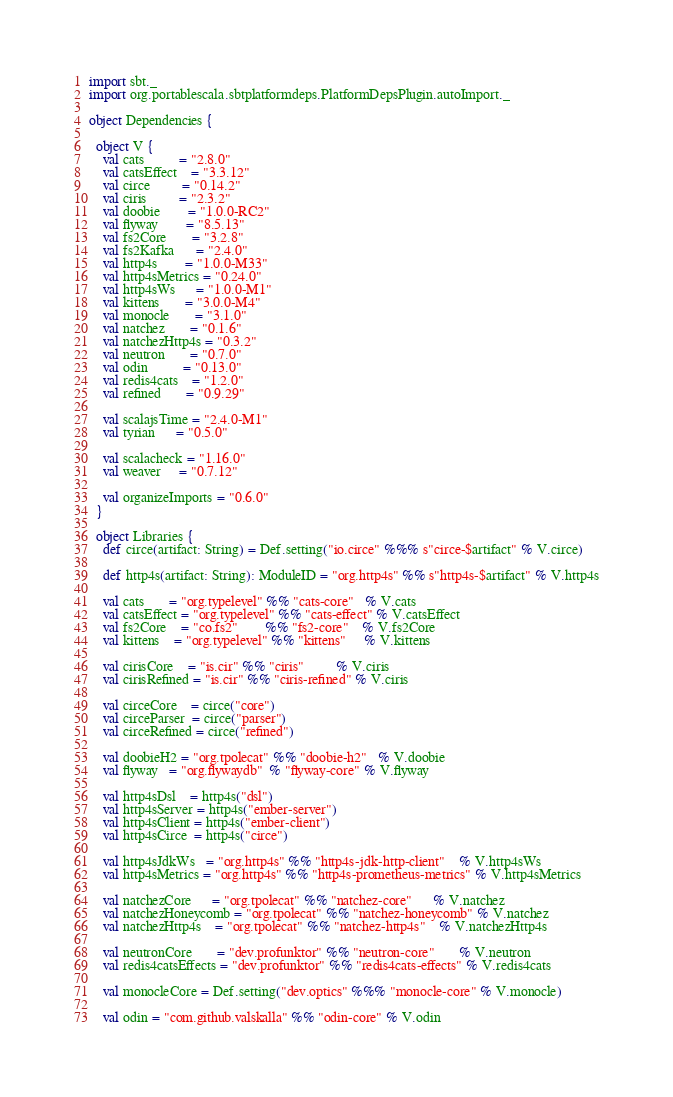<code> <loc_0><loc_0><loc_500><loc_500><_Scala_>import sbt._
import org.portablescala.sbtplatformdeps.PlatformDepsPlugin.autoImport._

object Dependencies {

  object V {
    val cats          = "2.8.0"
    val catsEffect    = "3.3.12"
    val circe         = "0.14.2"
    val ciris         = "2.3.2"
    val doobie        = "1.0.0-RC2"
    val flyway        = "8.5.13"
    val fs2Core       = "3.2.8"
    val fs2Kafka      = "2.4.0"
    val http4s        = "1.0.0-M33"
    val http4sMetrics = "0.24.0"
    val http4sWs      = "1.0.0-M1"
    val kittens       = "3.0.0-M4"
    val monocle       = "3.1.0"
    val natchez       = "0.1.6"
    val natchezHttp4s = "0.3.2"
    val neutron       = "0.7.0"
    val odin          = "0.13.0"
    val redis4cats    = "1.2.0"
    val refined       = "0.9.29"

    val scalajsTime = "2.4.0-M1"
    val tyrian      = "0.5.0"

    val scalacheck = "1.16.0"
    val weaver     = "0.7.12"

    val organizeImports = "0.6.0"
  }

  object Libraries {
    def circe(artifact: String) = Def.setting("io.circe" %%% s"circe-$artifact" % V.circe)

    def http4s(artifact: String): ModuleID = "org.http4s" %% s"http4s-$artifact" % V.http4s

    val cats       = "org.typelevel" %% "cats-core"   % V.cats
    val catsEffect = "org.typelevel" %% "cats-effect" % V.catsEffect
    val fs2Core    = "co.fs2"        %% "fs2-core"    % V.fs2Core
    val kittens    = "org.typelevel" %% "kittens"     % V.kittens

    val cirisCore    = "is.cir" %% "ciris"         % V.ciris
    val cirisRefined = "is.cir" %% "ciris-refined" % V.ciris

    val circeCore    = circe("core")
    val circeParser  = circe("parser")
    val circeRefined = circe("refined")

    val doobieH2 = "org.tpolecat" %% "doobie-h2"   % V.doobie
    val flyway   = "org.flywaydb"  % "flyway-core" % V.flyway

    val http4sDsl    = http4s("dsl")
    val http4sServer = http4s("ember-server")
    val http4sClient = http4s("ember-client")
    val http4sCirce  = http4s("circe")

    val http4sJdkWs   = "org.http4s" %% "http4s-jdk-http-client"    % V.http4sWs
    val http4sMetrics = "org.http4s" %% "http4s-prometheus-metrics" % V.http4sMetrics

    val natchezCore      = "org.tpolecat" %% "natchez-core"      % V.natchez
    val natchezHoneycomb = "org.tpolecat" %% "natchez-honeycomb" % V.natchez
    val natchezHttp4s    = "org.tpolecat" %% "natchez-http4s"    % V.natchezHttp4s

    val neutronCore       = "dev.profunktor" %% "neutron-core"       % V.neutron
    val redis4catsEffects = "dev.profunktor" %% "redis4cats-effects" % V.redis4cats

    val monocleCore = Def.setting("dev.optics" %%% "monocle-core" % V.monocle)

    val odin = "com.github.valskalla" %% "odin-core" % V.odin
</code> 